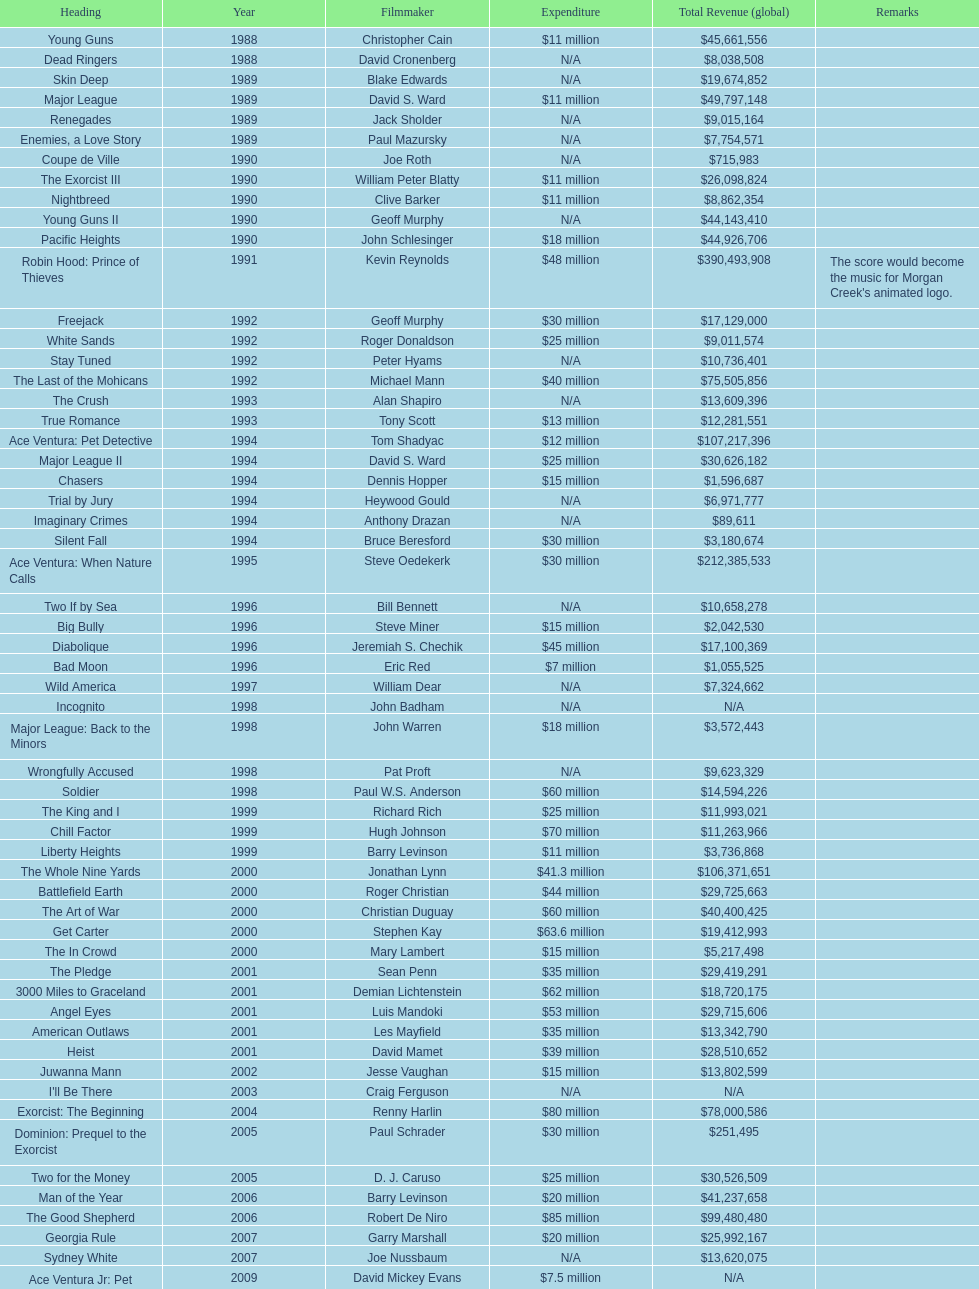Would you be able to parse every entry in this table? {'header': ['Heading', 'Year', 'Filmmaker', 'Expenditure', 'Total Revenue (global)', 'Remarks'], 'rows': [['Young Guns', '1988', 'Christopher Cain', '$11 million', '$45,661,556', ''], ['Dead Ringers', '1988', 'David Cronenberg', 'N/A', '$8,038,508', ''], ['Skin Deep', '1989', 'Blake Edwards', 'N/A', '$19,674,852', ''], ['Major League', '1989', 'David S. Ward', '$11 million', '$49,797,148', ''], ['Renegades', '1989', 'Jack Sholder', 'N/A', '$9,015,164', ''], ['Enemies, a Love Story', '1989', 'Paul Mazursky', 'N/A', '$7,754,571', ''], ['Coupe de Ville', '1990', 'Joe Roth', 'N/A', '$715,983', ''], ['The Exorcist III', '1990', 'William Peter Blatty', '$11 million', '$26,098,824', ''], ['Nightbreed', '1990', 'Clive Barker', '$11 million', '$8,862,354', ''], ['Young Guns II', '1990', 'Geoff Murphy', 'N/A', '$44,143,410', ''], ['Pacific Heights', '1990', 'John Schlesinger', '$18 million', '$44,926,706', ''], ['Robin Hood: Prince of Thieves', '1991', 'Kevin Reynolds', '$48 million', '$390,493,908', "The score would become the music for Morgan Creek's animated logo."], ['Freejack', '1992', 'Geoff Murphy', '$30 million', '$17,129,000', ''], ['White Sands', '1992', 'Roger Donaldson', '$25 million', '$9,011,574', ''], ['Stay Tuned', '1992', 'Peter Hyams', 'N/A', '$10,736,401', ''], ['The Last of the Mohicans', '1992', 'Michael Mann', '$40 million', '$75,505,856', ''], ['The Crush', '1993', 'Alan Shapiro', 'N/A', '$13,609,396', ''], ['True Romance', '1993', 'Tony Scott', '$13 million', '$12,281,551', ''], ['Ace Ventura: Pet Detective', '1994', 'Tom Shadyac', '$12 million', '$107,217,396', ''], ['Major League II', '1994', 'David S. Ward', '$25 million', '$30,626,182', ''], ['Chasers', '1994', 'Dennis Hopper', '$15 million', '$1,596,687', ''], ['Trial by Jury', '1994', 'Heywood Gould', 'N/A', '$6,971,777', ''], ['Imaginary Crimes', '1994', 'Anthony Drazan', 'N/A', '$89,611', ''], ['Silent Fall', '1994', 'Bruce Beresford', '$30 million', '$3,180,674', ''], ['Ace Ventura: When Nature Calls', '1995', 'Steve Oedekerk', '$30 million', '$212,385,533', ''], ['Two If by Sea', '1996', 'Bill Bennett', 'N/A', '$10,658,278', ''], ['Big Bully', '1996', 'Steve Miner', '$15 million', '$2,042,530', ''], ['Diabolique', '1996', 'Jeremiah S. Chechik', '$45 million', '$17,100,369', ''], ['Bad Moon', '1996', 'Eric Red', '$7 million', '$1,055,525', ''], ['Wild America', '1997', 'William Dear', 'N/A', '$7,324,662', ''], ['Incognito', '1998', 'John Badham', 'N/A', 'N/A', ''], ['Major League: Back to the Minors', '1998', 'John Warren', '$18 million', '$3,572,443', ''], ['Wrongfully Accused', '1998', 'Pat Proft', 'N/A', '$9,623,329', ''], ['Soldier', '1998', 'Paul W.S. Anderson', '$60 million', '$14,594,226', ''], ['The King and I', '1999', 'Richard Rich', '$25 million', '$11,993,021', ''], ['Chill Factor', '1999', 'Hugh Johnson', '$70 million', '$11,263,966', ''], ['Liberty Heights', '1999', 'Barry Levinson', '$11 million', '$3,736,868', ''], ['The Whole Nine Yards', '2000', 'Jonathan Lynn', '$41.3 million', '$106,371,651', ''], ['Battlefield Earth', '2000', 'Roger Christian', '$44 million', '$29,725,663', ''], ['The Art of War', '2000', 'Christian Duguay', '$60 million', '$40,400,425', ''], ['Get Carter', '2000', 'Stephen Kay', '$63.6 million', '$19,412,993', ''], ['The In Crowd', '2000', 'Mary Lambert', '$15 million', '$5,217,498', ''], ['The Pledge', '2001', 'Sean Penn', '$35 million', '$29,419,291', ''], ['3000 Miles to Graceland', '2001', 'Demian Lichtenstein', '$62 million', '$18,720,175', ''], ['Angel Eyes', '2001', 'Luis Mandoki', '$53 million', '$29,715,606', ''], ['American Outlaws', '2001', 'Les Mayfield', '$35 million', '$13,342,790', ''], ['Heist', '2001', 'David Mamet', '$39 million', '$28,510,652', ''], ['Juwanna Mann', '2002', 'Jesse Vaughan', '$15 million', '$13,802,599', ''], ["I'll Be There", '2003', 'Craig Ferguson', 'N/A', 'N/A', ''], ['Exorcist: The Beginning', '2004', 'Renny Harlin', '$80 million', '$78,000,586', ''], ['Dominion: Prequel to the Exorcist', '2005', 'Paul Schrader', '$30 million', '$251,495', ''], ['Two for the Money', '2005', 'D. J. Caruso', '$25 million', '$30,526,509', ''], ['Man of the Year', '2006', 'Barry Levinson', '$20 million', '$41,237,658', ''], ['The Good Shepherd', '2006', 'Robert De Niro', '$85 million', '$99,480,480', ''], ['Georgia Rule', '2007', 'Garry Marshall', '$20 million', '$25,992,167', ''], ['Sydney White', '2007', 'Joe Nussbaum', 'N/A', '$13,620,075', ''], ['Ace Ventura Jr: Pet Detective', '2009', 'David Mickey Evans', '$7.5 million', 'N/A', ''], ['Dream House', '2011', 'Jim Sheridan', '$50 million', '$38,502,340', ''], ['The Thing', '2011', 'Matthijs van Heijningen Jr.', '$38 million', '$27,428,670', ''], ['Tupac', '2014', 'Antoine Fuqua', '$45 million', '', '']]} What is the number of films directed by david s. ward? 2. 